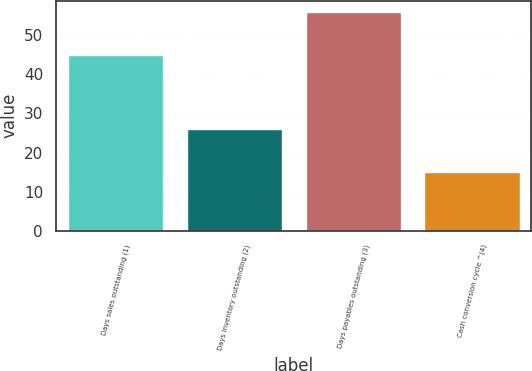<chart> <loc_0><loc_0><loc_500><loc_500><bar_chart><fcel>Days sales outstanding (1)<fcel>Days inventory outstanding (2)<fcel>Days payables outstanding (3)<fcel>Cash conversion cycle ^(4)<nl><fcel>45<fcel>26<fcel>56<fcel>15<nl></chart> 